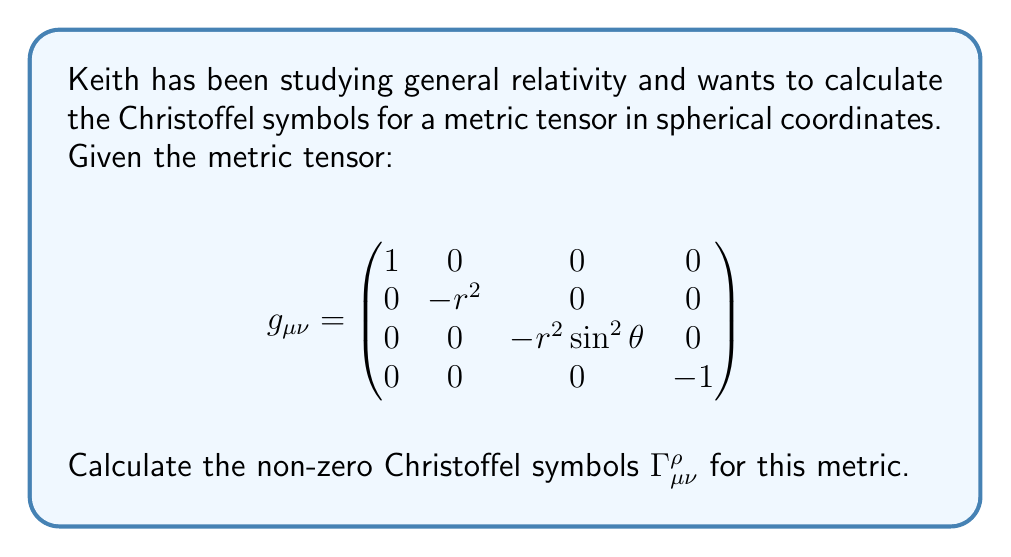Can you solve this math problem? To calculate the Christoffel symbols, we use the formula:

$$\Gamma^\rho_{\mu\nu} = \frac{1}{2}g^{\rho\sigma}(\partial_\mu g_{\nu\sigma} + \partial_\nu g_{\mu\sigma} - \partial_\sigma g_{\mu\nu})$$

Step 1: Calculate the inverse metric tensor $g^{\mu\nu}$:
$$g^{\mu\nu} = \begin{pmatrix}
1 & 0 & 0 & 0 \\
0 & -\frac{1}{r^2} & 0 & 0 \\
0 & 0 & -\frac{1}{r^2\sin^2\theta} & 0 \\
0 & 0 & 0 & -1
\end{pmatrix}$$

Step 2: Calculate the partial derivatives of the metric tensor components:
$\partial_r g_{\theta\theta} = -2r$
$\partial_r g_{\phi\phi} = -2r\sin^2\theta$
$\partial_\theta g_{\phi\phi} = -2r^2\sin\theta\cos\theta$

Step 3: Calculate the non-zero Christoffel symbols:

$\Gamma^r_{\theta\theta} = \frac{1}{2}g^{rr}(-\partial_r g_{\theta\theta}) = -\frac{1}{2}(-\frac{1}{r^2})(-2r) = r$

$\Gamma^r_{\phi\phi} = \frac{1}{2}g^{rr}(-\partial_r g_{\phi\phi}) = -\frac{1}{2}(-\frac{1}{r^2})(-2r\sin^2\theta) = r\sin^2\theta$

$\Gamma^\theta_{\phi\phi} = \frac{1}{2}g^{\theta\theta}(-\partial_\theta g_{\phi\phi}) = -\frac{1}{2}(-\frac{1}{r^2\sin^2\theta})(-2r^2\sin\theta\cos\theta) = \sin\theta\cos\theta$

$\Gamma^\theta_{r\theta} = \Gamma^\theta_{\theta r} = \frac{1}{2}g^{\theta\theta}(\partial_r g_{\theta\theta}) = \frac{1}{2}(-\frac{1}{r^2})(2r) = -\frac{1}{r}$

$\Gamma^\phi_{r\phi} = \Gamma^\phi_{\phi r} = \frac{1}{2}g^{\phi\phi}(\partial_r g_{\phi\phi}) = \frac{1}{2}(-\frac{1}{r^2\sin^2\theta})(2r\sin^2\theta) = -\frac{1}{r}$

$\Gamma^\phi_{\theta\phi} = \Gamma^\phi_{\phi\theta} = \frac{1}{2}g^{\phi\phi}(\partial_\theta g_{\phi\phi}) = \frac{1}{2}(-\frac{1}{r^2\sin^2\theta})(2r^2\sin\theta\cos\theta) = -\cot\theta$
Answer: $\Gamma^r_{\theta\theta} = r$, $\Gamma^r_{\phi\phi} = r\sin^2\theta$, $\Gamma^\theta_{\phi\phi} = \sin\theta\cos\theta$, $\Gamma^\theta_{r\theta} = \Gamma^\theta_{\theta r} = -\frac{1}{r}$, $\Gamma^\phi_{r\phi} = \Gamma^\phi_{\phi r} = -\frac{1}{r}$, $\Gamma^\phi_{\theta\phi} = \Gamma^\phi_{\phi\theta} = -\cot\theta$ 